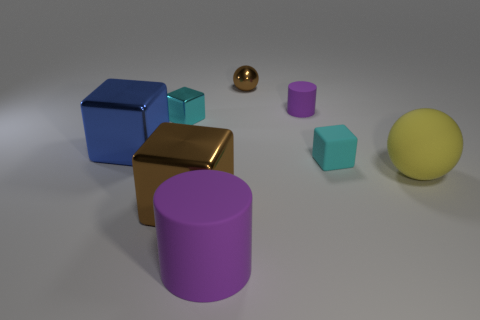Subtract all red cylinders. How many cyan cubes are left? 2 Subtract all metallic blocks. How many blocks are left? 1 Subtract all blue cubes. How many cubes are left? 3 Add 1 small rubber things. How many objects exist? 9 Subtract all balls. How many objects are left? 6 Subtract all blue blocks. Subtract all yellow cylinders. How many blocks are left? 3 Add 5 tiny cubes. How many tiny cubes are left? 7 Add 8 yellow rubber balls. How many yellow rubber balls exist? 9 Subtract 1 brown cubes. How many objects are left? 7 Subtract all tiny rubber cylinders. Subtract all brown cubes. How many objects are left? 6 